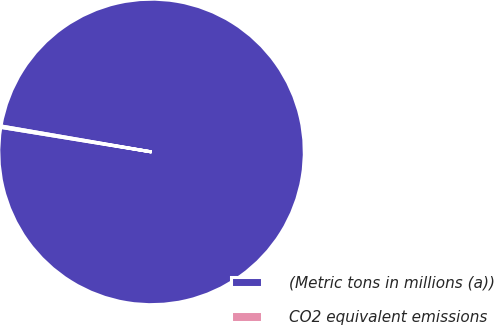Convert chart to OTSL. <chart><loc_0><loc_0><loc_500><loc_500><pie_chart><fcel>(Metric tons in millions (a))<fcel>CO2 equivalent emissions<nl><fcel>99.85%<fcel>0.15%<nl></chart> 